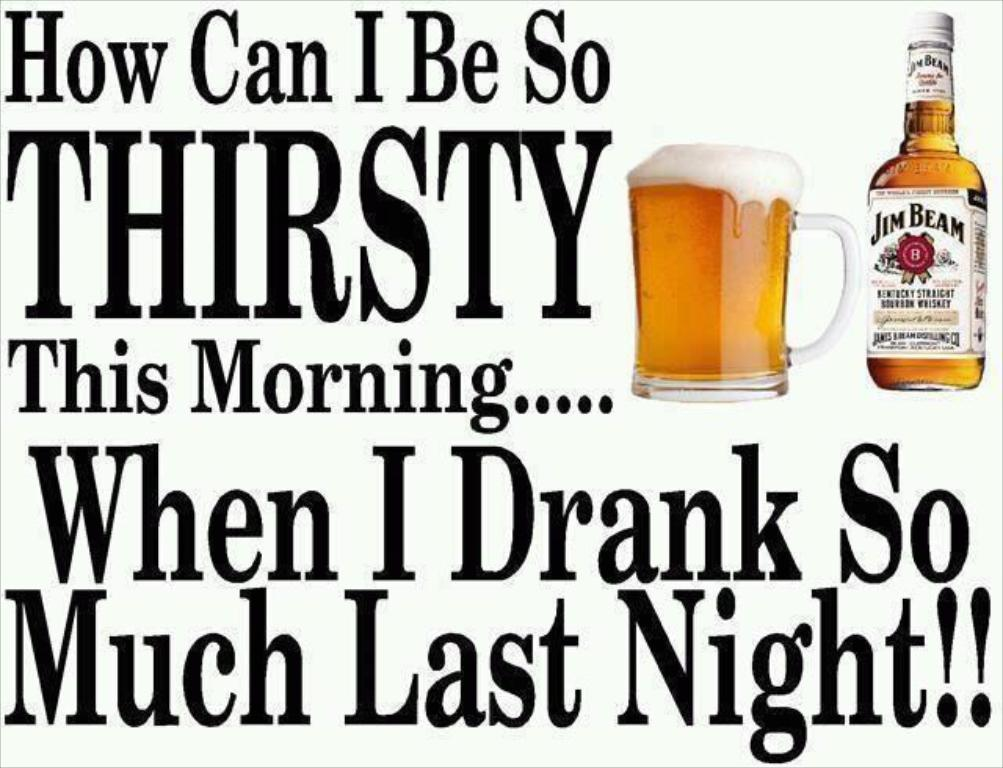Provide a one-sentence caption for the provided image. An advertisement for Jim Beam starts with the phrase "How can I be so thirsty this morning...". 